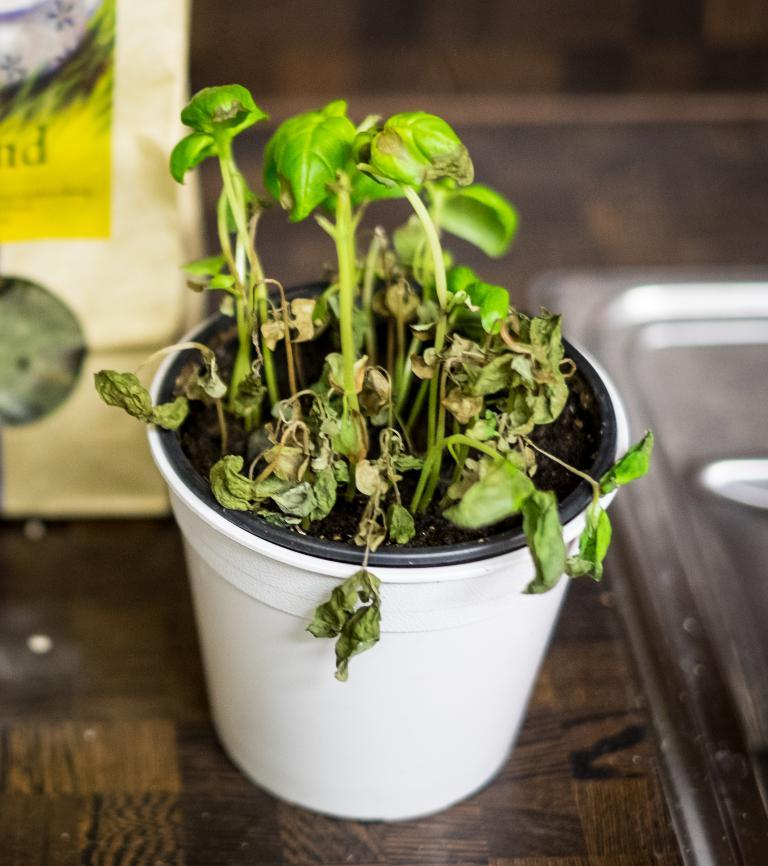What is the main subject in the middle of the image? There is a flower pot in the middle of the image. What can be seen on the left side of the image? There is an object on the left side of the image. What type of surface is visible in the background? The background appears to be a kitchen countertop. What type of harmony is being played by the band in the image? There is no band or music present in the image; it features a flower pot and an object on a kitchen countertop. 